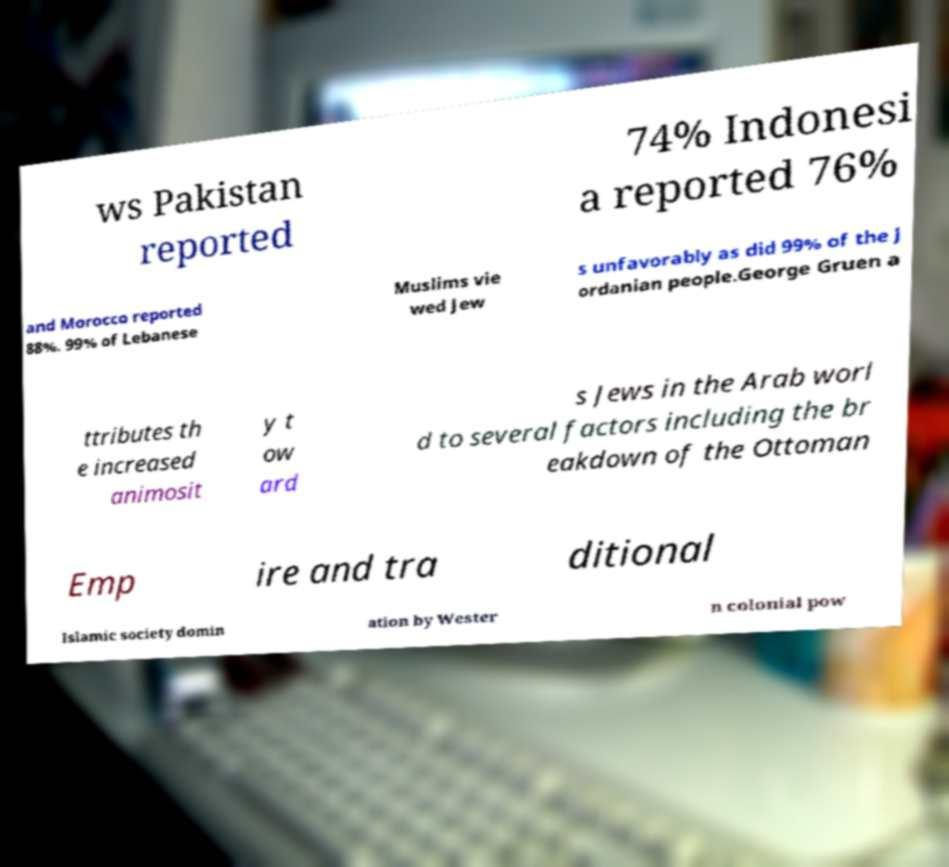Could you extract and type out the text from this image? ws Pakistan reported 74% Indonesi a reported 76% and Morocco reported 88%. 99% of Lebanese Muslims vie wed Jew s unfavorably as did 99% of the J ordanian people.George Gruen a ttributes th e increased animosit y t ow ard s Jews in the Arab worl d to several factors including the br eakdown of the Ottoman Emp ire and tra ditional Islamic society domin ation by Wester n colonial pow 